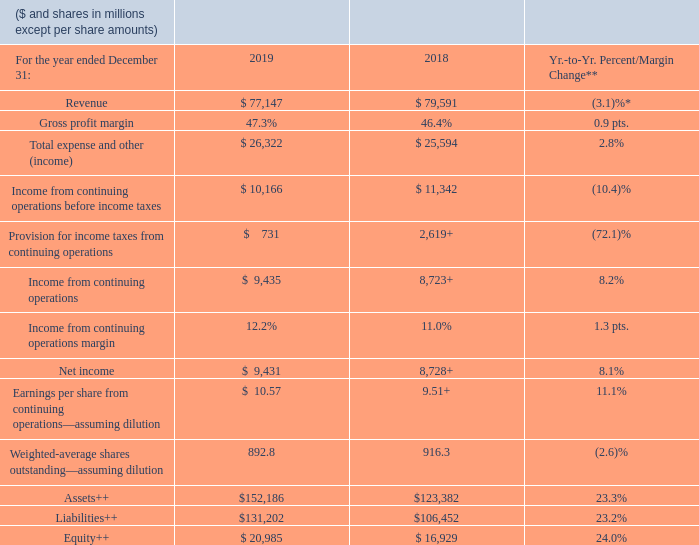MANAGEMENT DISCUSSION SNAPSHOT
* (1.0) percent adjusted for currency; 0.2 percent excluding divested businesses and adjusted for currency.
** 2019 results were impacted by Red Hat purchase accounting and acquisition-related activity.
+ Includes charges of $2.0 billion or $2.23 of diluted earnings per share in 2018 associated with U.S. tax reform.
++At December 31
How has the revenue year to year change been adjusted? (1.0) percent adjusted for currency; 0.2 percent excluding divested businesses and adjusted for currency. What impacted the 2019 results? 2019 results were impacted by red hat purchase accounting and acquisition-related activity. What charges were included in 2018? Includes charges of $2.0 billion or $2.23 of diluted earnings per share in 2018 associated with u.s. tax reform. What was the increase / (decrease) in revenue from 2018 to 2019?
Answer scale should be: million. 77,147 - 79,591
Answer: -2444. What was the total assets turnover ratio in 2019?
Answer scale should be: percent. 77,147 / 152,186
Answer: 50.69. What was the percentage increase / (decrease) in the net income from 2018 to 2019?
Answer scale should be: percent. 9,431 / 8,728 - 1
Answer: 8.05. 